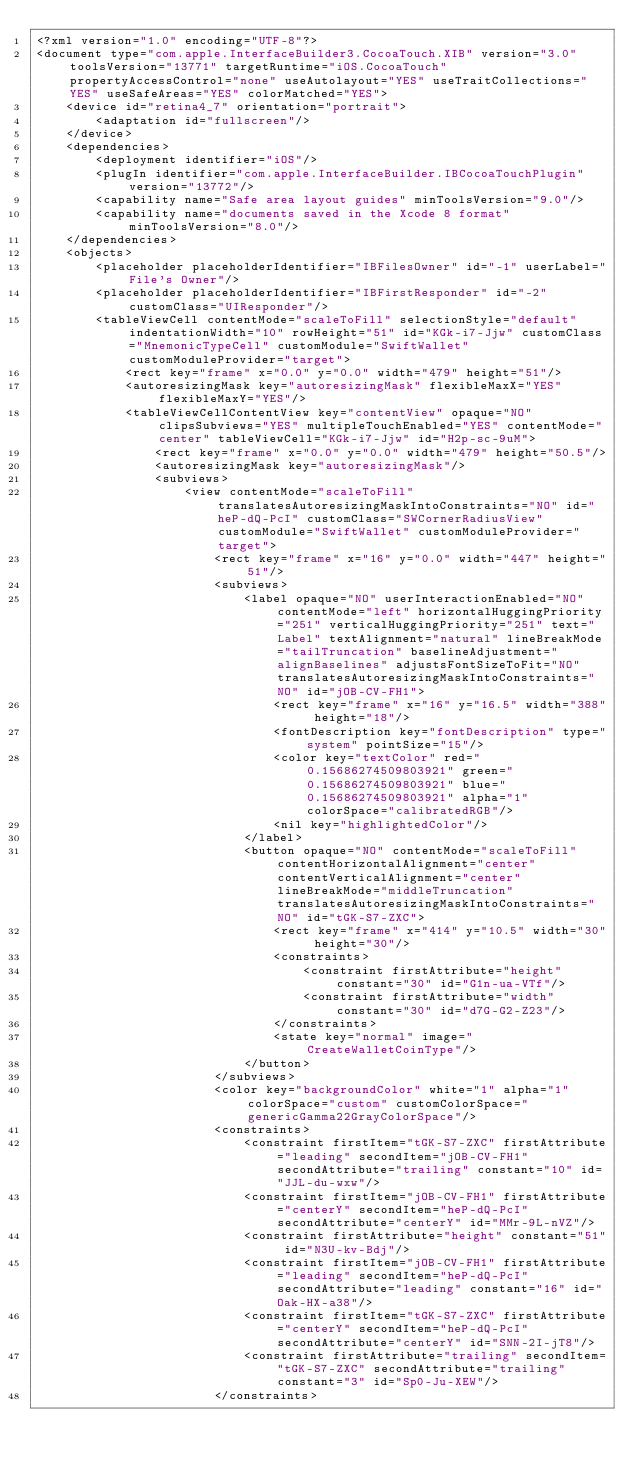<code> <loc_0><loc_0><loc_500><loc_500><_XML_><?xml version="1.0" encoding="UTF-8"?>
<document type="com.apple.InterfaceBuilder3.CocoaTouch.XIB" version="3.0" toolsVersion="13771" targetRuntime="iOS.CocoaTouch" propertyAccessControl="none" useAutolayout="YES" useTraitCollections="YES" useSafeAreas="YES" colorMatched="YES">
    <device id="retina4_7" orientation="portrait">
        <adaptation id="fullscreen"/>
    </device>
    <dependencies>
        <deployment identifier="iOS"/>
        <plugIn identifier="com.apple.InterfaceBuilder.IBCocoaTouchPlugin" version="13772"/>
        <capability name="Safe area layout guides" minToolsVersion="9.0"/>
        <capability name="documents saved in the Xcode 8 format" minToolsVersion="8.0"/>
    </dependencies>
    <objects>
        <placeholder placeholderIdentifier="IBFilesOwner" id="-1" userLabel="File's Owner"/>
        <placeholder placeholderIdentifier="IBFirstResponder" id="-2" customClass="UIResponder"/>
        <tableViewCell contentMode="scaleToFill" selectionStyle="default" indentationWidth="10" rowHeight="51" id="KGk-i7-Jjw" customClass="MnemonicTypeCell" customModule="SwiftWallet" customModuleProvider="target">
            <rect key="frame" x="0.0" y="0.0" width="479" height="51"/>
            <autoresizingMask key="autoresizingMask" flexibleMaxX="YES" flexibleMaxY="YES"/>
            <tableViewCellContentView key="contentView" opaque="NO" clipsSubviews="YES" multipleTouchEnabled="YES" contentMode="center" tableViewCell="KGk-i7-Jjw" id="H2p-sc-9uM">
                <rect key="frame" x="0.0" y="0.0" width="479" height="50.5"/>
                <autoresizingMask key="autoresizingMask"/>
                <subviews>
                    <view contentMode="scaleToFill" translatesAutoresizingMaskIntoConstraints="NO" id="heP-dQ-PcI" customClass="SWCornerRadiusView" customModule="SwiftWallet" customModuleProvider="target">
                        <rect key="frame" x="16" y="0.0" width="447" height="51"/>
                        <subviews>
                            <label opaque="NO" userInteractionEnabled="NO" contentMode="left" horizontalHuggingPriority="251" verticalHuggingPriority="251" text="Label" textAlignment="natural" lineBreakMode="tailTruncation" baselineAdjustment="alignBaselines" adjustsFontSizeToFit="NO" translatesAutoresizingMaskIntoConstraints="NO" id="jOB-CV-FH1">
                                <rect key="frame" x="16" y="16.5" width="388" height="18"/>
                                <fontDescription key="fontDescription" type="system" pointSize="15"/>
                                <color key="textColor" red="0.15686274509803921" green="0.15686274509803921" blue="0.15686274509803921" alpha="1" colorSpace="calibratedRGB"/>
                                <nil key="highlightedColor"/>
                            </label>
                            <button opaque="NO" contentMode="scaleToFill" contentHorizontalAlignment="center" contentVerticalAlignment="center" lineBreakMode="middleTruncation" translatesAutoresizingMaskIntoConstraints="NO" id="tGK-S7-ZXC">
                                <rect key="frame" x="414" y="10.5" width="30" height="30"/>
                                <constraints>
                                    <constraint firstAttribute="height" constant="30" id="G1n-ua-VTf"/>
                                    <constraint firstAttribute="width" constant="30" id="d7G-G2-Z23"/>
                                </constraints>
                                <state key="normal" image="CreateWalletCoinType"/>
                            </button>
                        </subviews>
                        <color key="backgroundColor" white="1" alpha="1" colorSpace="custom" customColorSpace="genericGamma22GrayColorSpace"/>
                        <constraints>
                            <constraint firstItem="tGK-S7-ZXC" firstAttribute="leading" secondItem="jOB-CV-FH1" secondAttribute="trailing" constant="10" id="JJL-du-wxw"/>
                            <constraint firstItem="jOB-CV-FH1" firstAttribute="centerY" secondItem="heP-dQ-PcI" secondAttribute="centerY" id="MMr-9L-nVZ"/>
                            <constraint firstAttribute="height" constant="51" id="N3U-kv-Bdj"/>
                            <constraint firstItem="jOB-CV-FH1" firstAttribute="leading" secondItem="heP-dQ-PcI" secondAttribute="leading" constant="16" id="Oak-HX-a38"/>
                            <constraint firstItem="tGK-S7-ZXC" firstAttribute="centerY" secondItem="heP-dQ-PcI" secondAttribute="centerY" id="SNN-2I-jT8"/>
                            <constraint firstAttribute="trailing" secondItem="tGK-S7-ZXC" secondAttribute="trailing" constant="3" id="Sp0-Ju-XEW"/>
                        </constraints></code> 